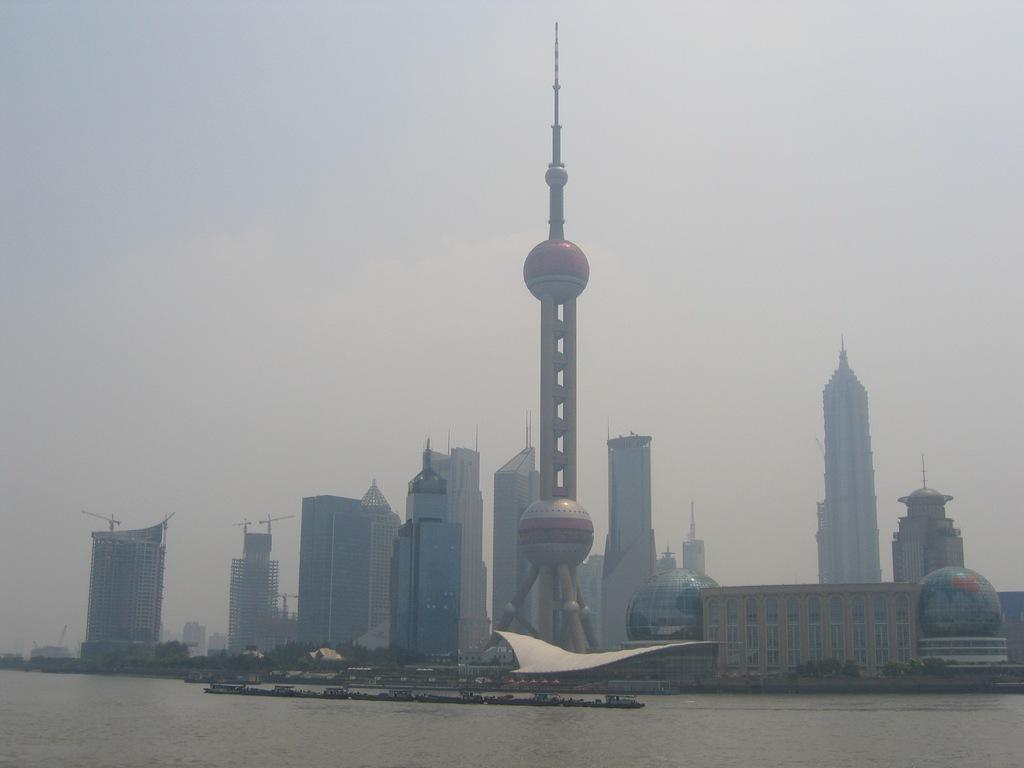What type of buildings can be seen in the image? There are skyscrapers and a tower in the image. What is located at the bottom of the image? There is water visible at the bottom of the image. What is visible at the top of the image? The sky is visible at the top of the image. What type of oil is being used to lubricate the representative's way in the image? There is no representative or oil present in the image. 